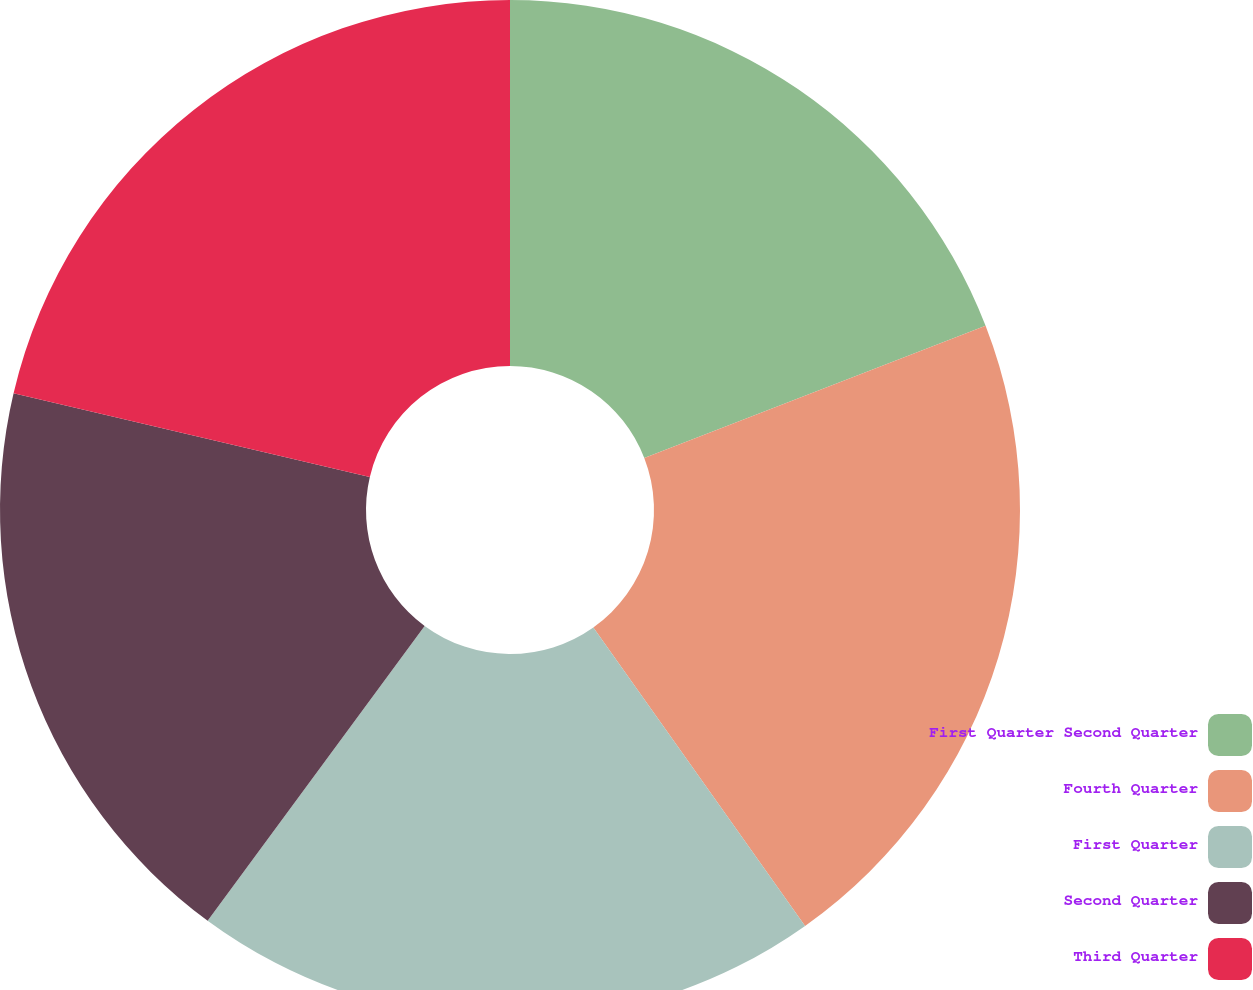Convert chart. <chart><loc_0><loc_0><loc_500><loc_500><pie_chart><fcel>First Quarter Second Quarter<fcel>Fourth Quarter<fcel>First Quarter<fcel>Second Quarter<fcel>Third Quarter<nl><fcel>19.12%<fcel>21.06%<fcel>19.92%<fcel>18.58%<fcel>21.32%<nl></chart> 